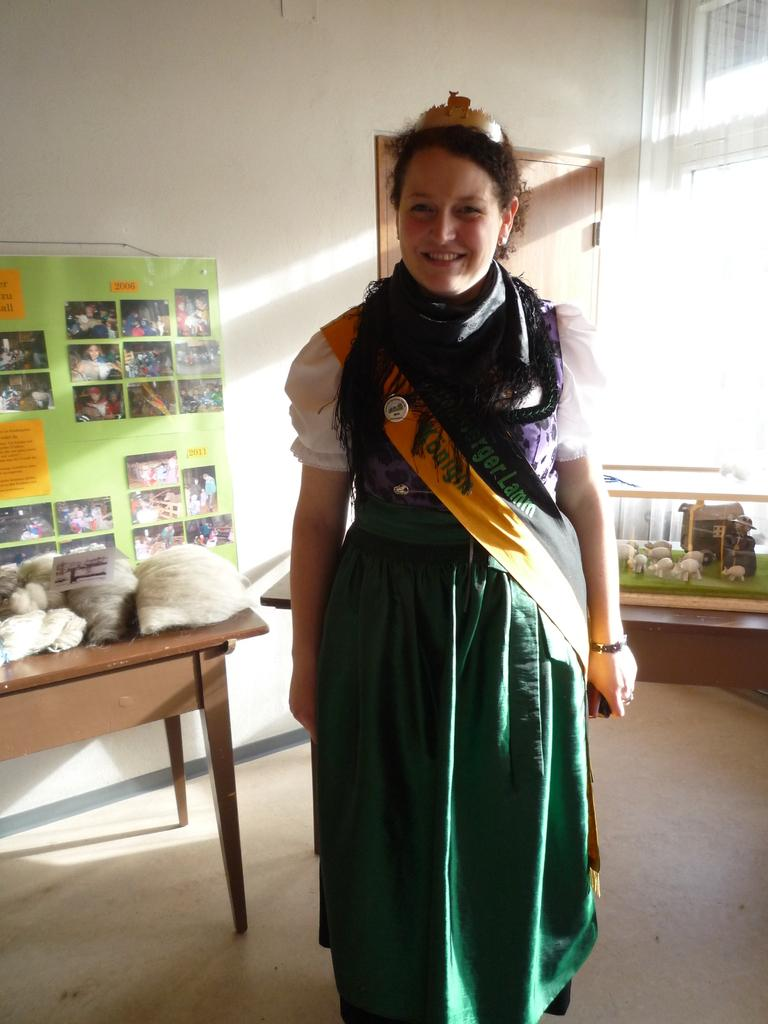Who is present in the image? There is a woman in the image. What is the woman doing in the image? The woman is standing and smiling. What can be seen in the background of the image? There is a table, a poster on the wall, a door, a window, and toys in the background of the image. What is on the table in the background? There are clothes on the table. What type of cow can be seen going on vacation in the image? There is no cow or vacation depicted in the image. 